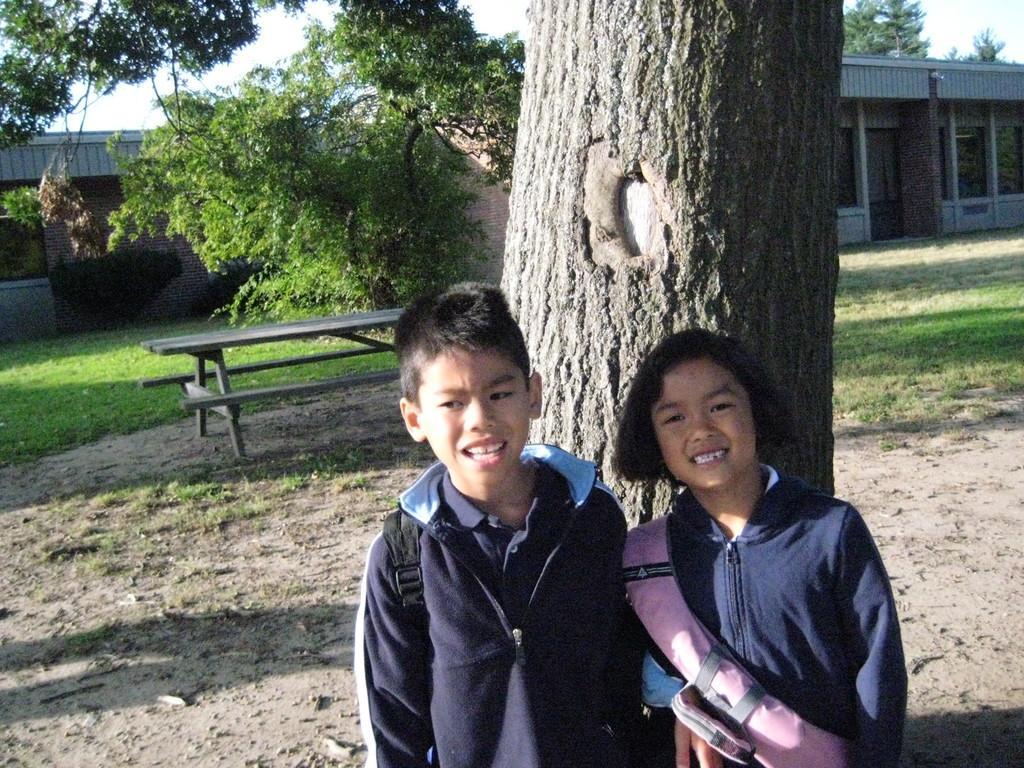In one or two sentences, can you explain what this image depicts? In this image in front there are two people. Behind them there is a tree. In the center of the image there is a table. In the background of the image there are trees, buildings and sky. At the bottom of the image there is grass on the surface. 